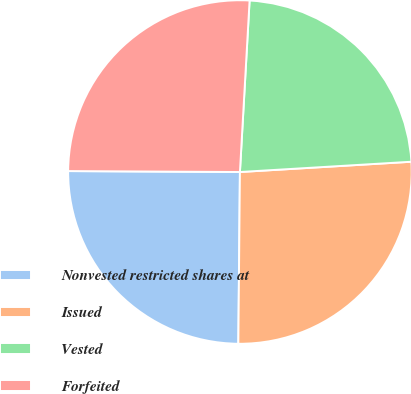<chart> <loc_0><loc_0><loc_500><loc_500><pie_chart><fcel>Nonvested restricted shares at<fcel>Issued<fcel>Vested<fcel>Forfeited<nl><fcel>24.94%<fcel>26.1%<fcel>23.15%<fcel>25.81%<nl></chart> 